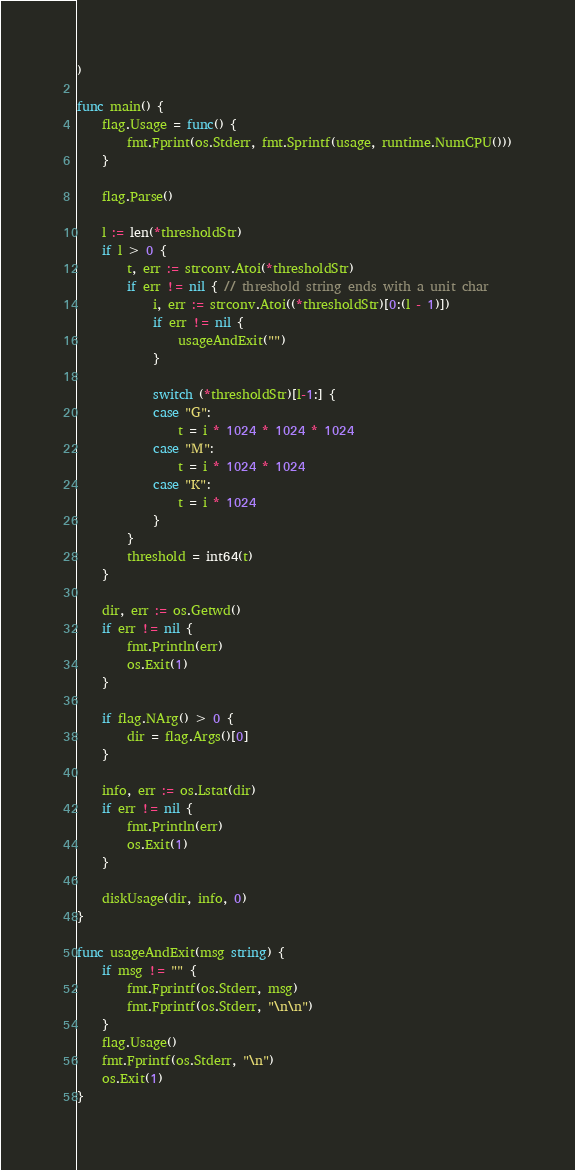<code> <loc_0><loc_0><loc_500><loc_500><_Go_>)

func main() {
	flag.Usage = func() {
		fmt.Fprint(os.Stderr, fmt.Sprintf(usage, runtime.NumCPU()))
	}

	flag.Parse()

	l := len(*thresholdStr)
	if l > 0 {
		t, err := strconv.Atoi(*thresholdStr)
		if err != nil { // threshold string ends with a unit char
			i, err := strconv.Atoi((*thresholdStr)[0:(l - 1)])
			if err != nil {
				usageAndExit("")
			}

			switch (*thresholdStr)[l-1:] {
			case "G":
				t = i * 1024 * 1024 * 1024
			case "M":
				t = i * 1024 * 1024
			case "K":
				t = i * 1024
			}
		}
		threshold = int64(t)
	}

	dir, err := os.Getwd()
	if err != nil {
		fmt.Println(err)
		os.Exit(1)
	}

	if flag.NArg() > 0 {
		dir = flag.Args()[0]
	}

	info, err := os.Lstat(dir)
	if err != nil {
		fmt.Println(err)
		os.Exit(1)
	}

	diskUsage(dir, info, 0)
}

func usageAndExit(msg string) {
	if msg != "" {
		fmt.Fprintf(os.Stderr, msg)
		fmt.Fprintf(os.Stderr, "\n\n")
	}
	flag.Usage()
	fmt.Fprintf(os.Stderr, "\n")
	os.Exit(1)
}
</code> 